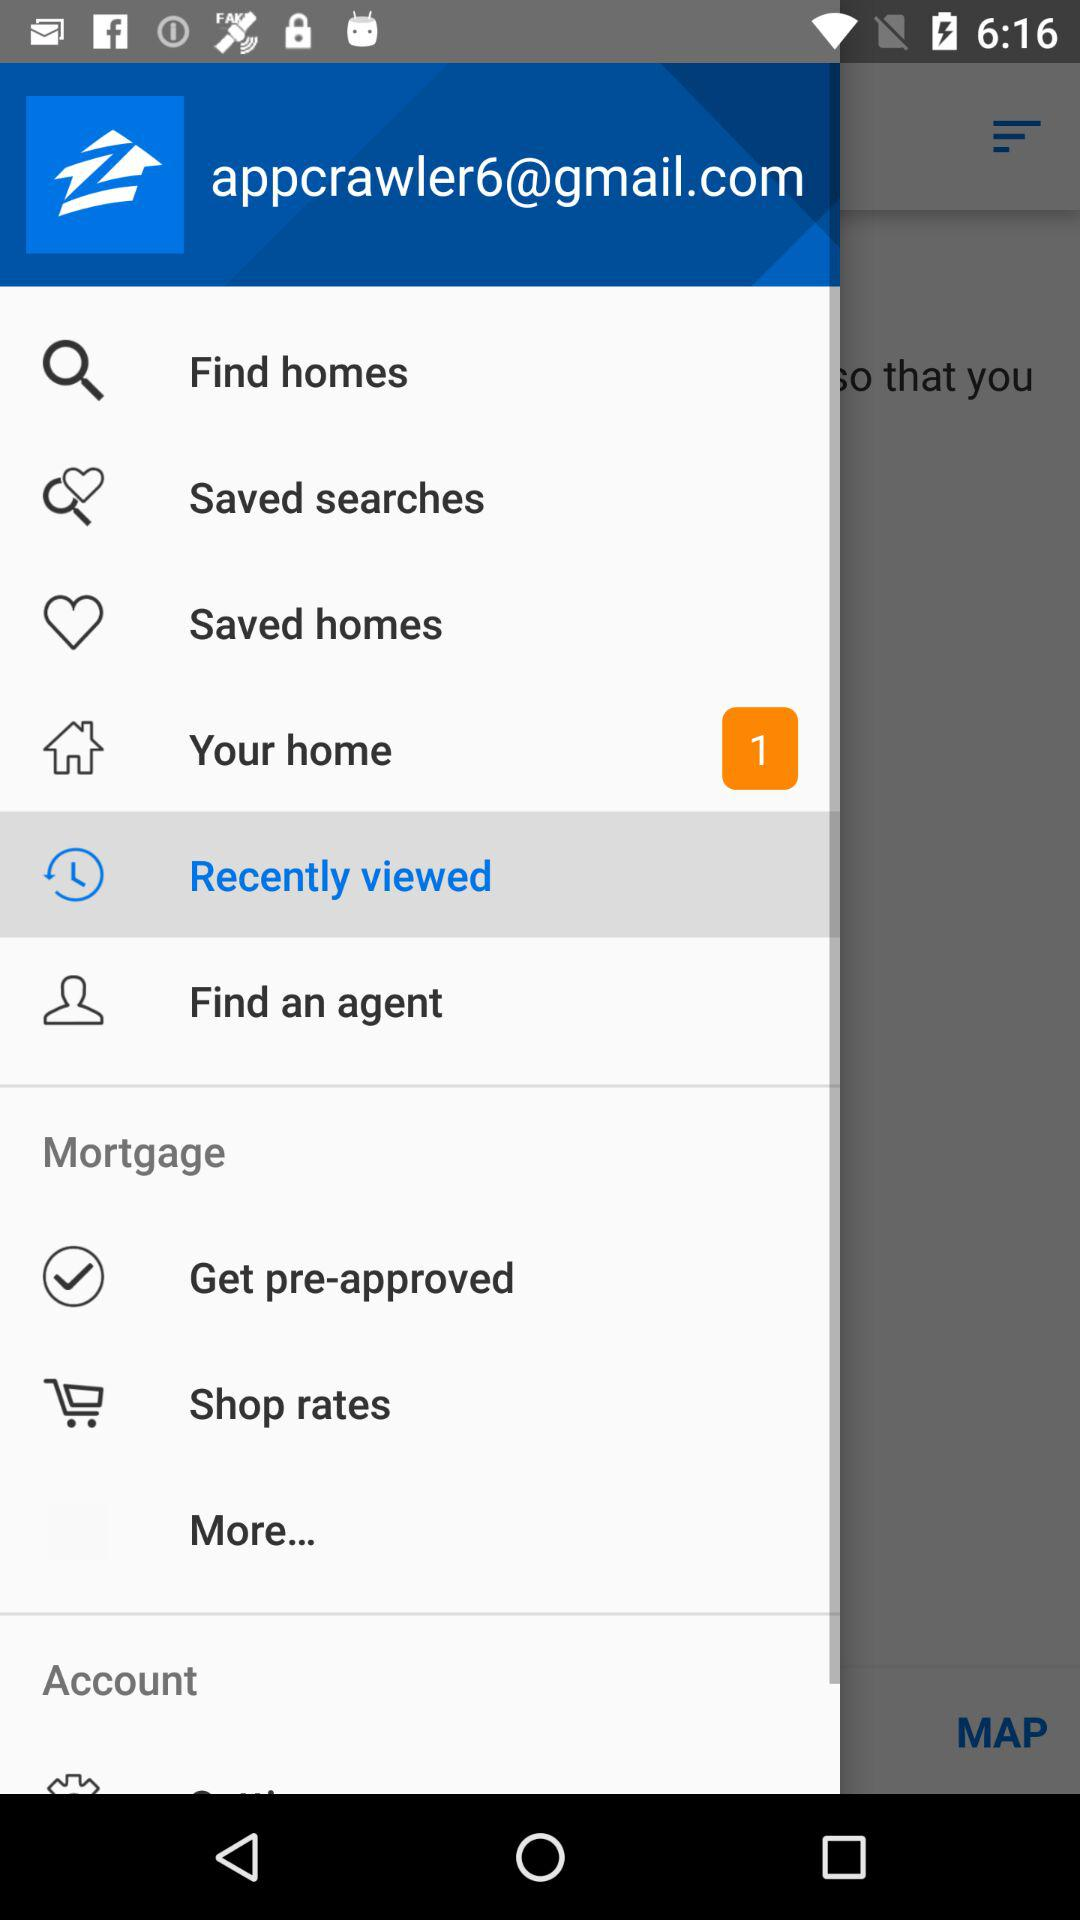What is the email address? The email address is appcrawler6@gmail.com. 